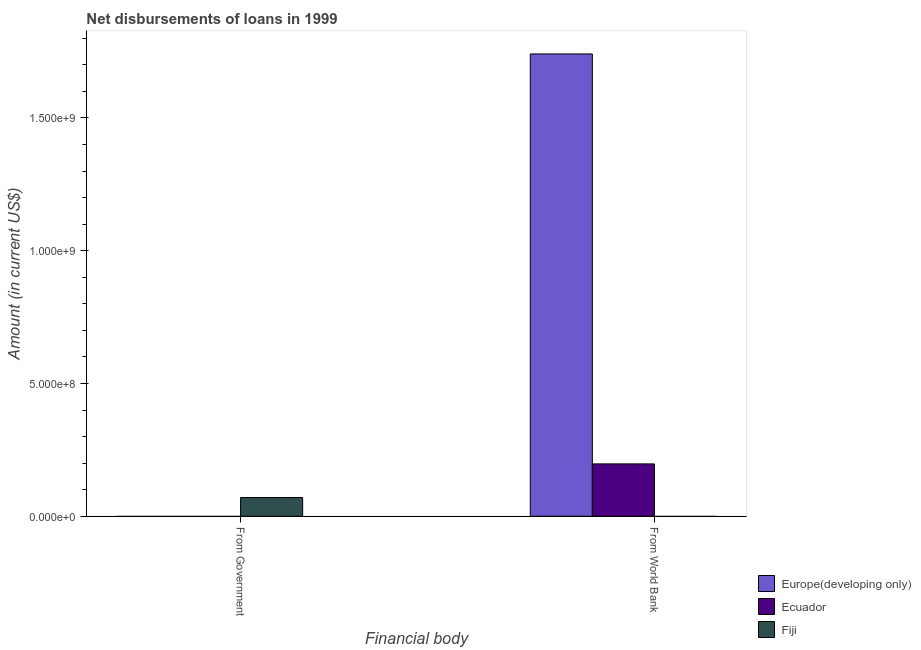Are the number of bars per tick equal to the number of legend labels?
Provide a short and direct response. No. Are the number of bars on each tick of the X-axis equal?
Offer a very short reply. No. What is the label of the 2nd group of bars from the left?
Give a very brief answer. From World Bank. Across all countries, what is the maximum net disbursements of loan from world bank?
Ensure brevity in your answer.  1.74e+09. In which country was the net disbursements of loan from government maximum?
Keep it short and to the point. Fiji. What is the total net disbursements of loan from world bank in the graph?
Provide a succinct answer. 1.94e+09. What is the difference between the net disbursements of loan from government in Fiji and the net disbursements of loan from world bank in Ecuador?
Provide a short and direct response. -1.27e+08. What is the average net disbursements of loan from world bank per country?
Keep it short and to the point. 6.46e+08. In how many countries, is the net disbursements of loan from government greater than the average net disbursements of loan from government taken over all countries?
Offer a terse response. 1. How many countries are there in the graph?
Your answer should be very brief. 3. Does the graph contain any zero values?
Offer a very short reply. Yes. How many legend labels are there?
Keep it short and to the point. 3. How are the legend labels stacked?
Give a very brief answer. Vertical. What is the title of the graph?
Provide a succinct answer. Net disbursements of loans in 1999. Does "New Caledonia" appear as one of the legend labels in the graph?
Your answer should be very brief. No. What is the label or title of the X-axis?
Your answer should be compact. Financial body. What is the Amount (in current US$) in Europe(developing only) in From Government?
Keep it short and to the point. 0. What is the Amount (in current US$) of Fiji in From Government?
Offer a very short reply. 7.06e+07. What is the Amount (in current US$) of Europe(developing only) in From World Bank?
Make the answer very short. 1.74e+09. What is the Amount (in current US$) in Ecuador in From World Bank?
Give a very brief answer. 1.97e+08. What is the Amount (in current US$) of Fiji in From World Bank?
Ensure brevity in your answer.  0. Across all Financial body, what is the maximum Amount (in current US$) in Europe(developing only)?
Make the answer very short. 1.74e+09. Across all Financial body, what is the maximum Amount (in current US$) in Ecuador?
Offer a terse response. 1.97e+08. Across all Financial body, what is the maximum Amount (in current US$) of Fiji?
Your response must be concise. 7.06e+07. Across all Financial body, what is the minimum Amount (in current US$) in Europe(developing only)?
Ensure brevity in your answer.  0. What is the total Amount (in current US$) in Europe(developing only) in the graph?
Your answer should be very brief. 1.74e+09. What is the total Amount (in current US$) of Ecuador in the graph?
Keep it short and to the point. 1.97e+08. What is the total Amount (in current US$) in Fiji in the graph?
Keep it short and to the point. 7.06e+07. What is the average Amount (in current US$) of Europe(developing only) per Financial body?
Offer a very short reply. 8.71e+08. What is the average Amount (in current US$) in Ecuador per Financial body?
Ensure brevity in your answer.  9.86e+07. What is the average Amount (in current US$) of Fiji per Financial body?
Make the answer very short. 3.53e+07. What is the difference between the Amount (in current US$) in Europe(developing only) and Amount (in current US$) in Ecuador in From World Bank?
Your response must be concise. 1.54e+09. What is the difference between the highest and the lowest Amount (in current US$) of Europe(developing only)?
Provide a succinct answer. 1.74e+09. What is the difference between the highest and the lowest Amount (in current US$) in Ecuador?
Provide a short and direct response. 1.97e+08. What is the difference between the highest and the lowest Amount (in current US$) of Fiji?
Keep it short and to the point. 7.06e+07. 